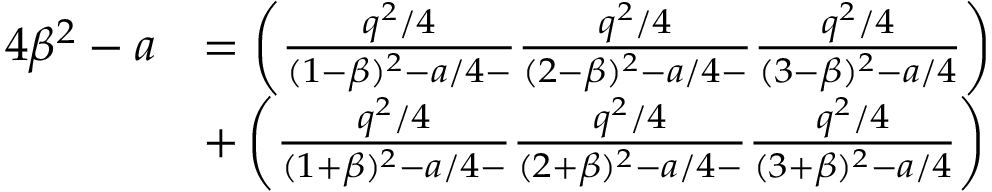<formula> <loc_0><loc_0><loc_500><loc_500>\begin{array} { r l } { 4 \beta ^ { 2 } - a } & { = \left ( \frac { q ^ { 2 } / 4 } { ( 1 - \beta ) ^ { 2 } - a / 4 - } \frac { q ^ { 2 } / 4 } { ( 2 - \beta ) ^ { 2 } - a / 4 - } \frac { q ^ { 2 } / 4 } { ( 3 - \beta ) ^ { 2 } - a / 4 } \right ) } \\ & { + \left ( \frac { q ^ { 2 } / 4 } { ( 1 + \beta ) ^ { 2 } - a / 4 - } \frac { q ^ { 2 } / 4 } { ( 2 + \beta ) ^ { 2 } - a / 4 - } \frac { q ^ { 2 } / 4 } { ( 3 + \beta ) ^ { 2 } - a / 4 } \right ) } \end{array}</formula> 